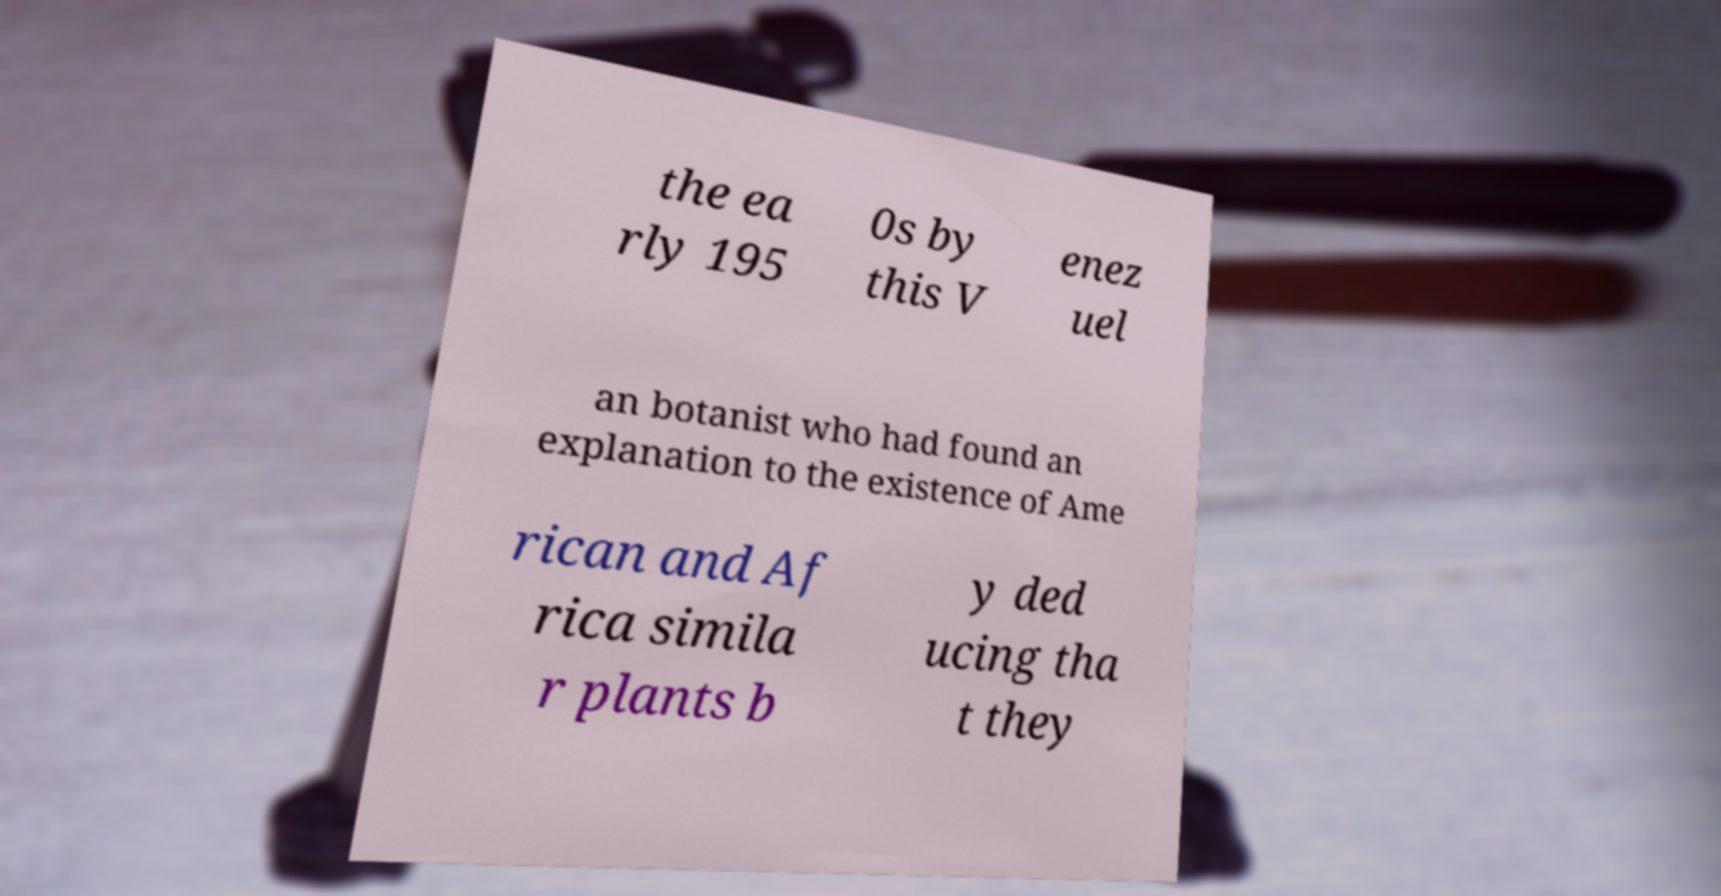I need the written content from this picture converted into text. Can you do that? the ea rly 195 0s by this V enez uel an botanist who had found an explanation to the existence of Ame rican and Af rica simila r plants b y ded ucing tha t they 